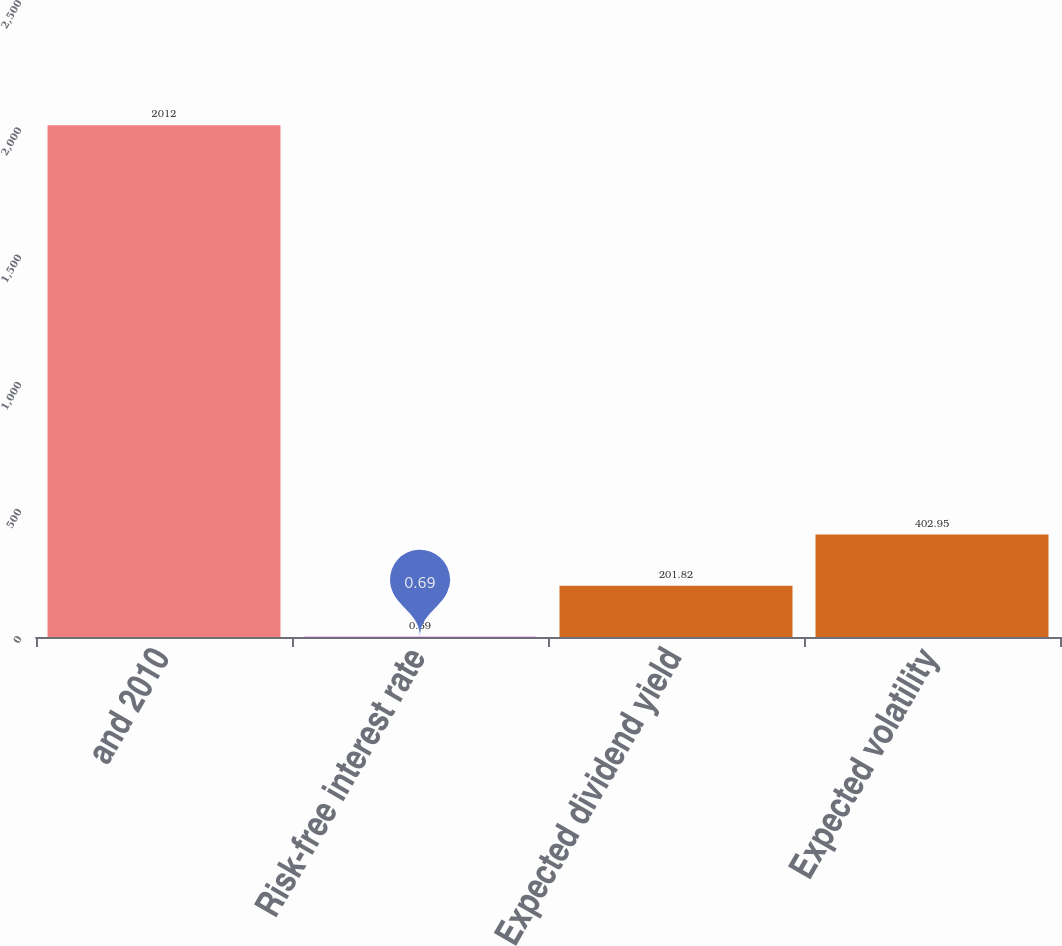Convert chart. <chart><loc_0><loc_0><loc_500><loc_500><bar_chart><fcel>and 2010<fcel>Risk-free interest rate<fcel>Expected dividend yield<fcel>Expected volatility<nl><fcel>2012<fcel>0.69<fcel>201.82<fcel>402.95<nl></chart> 